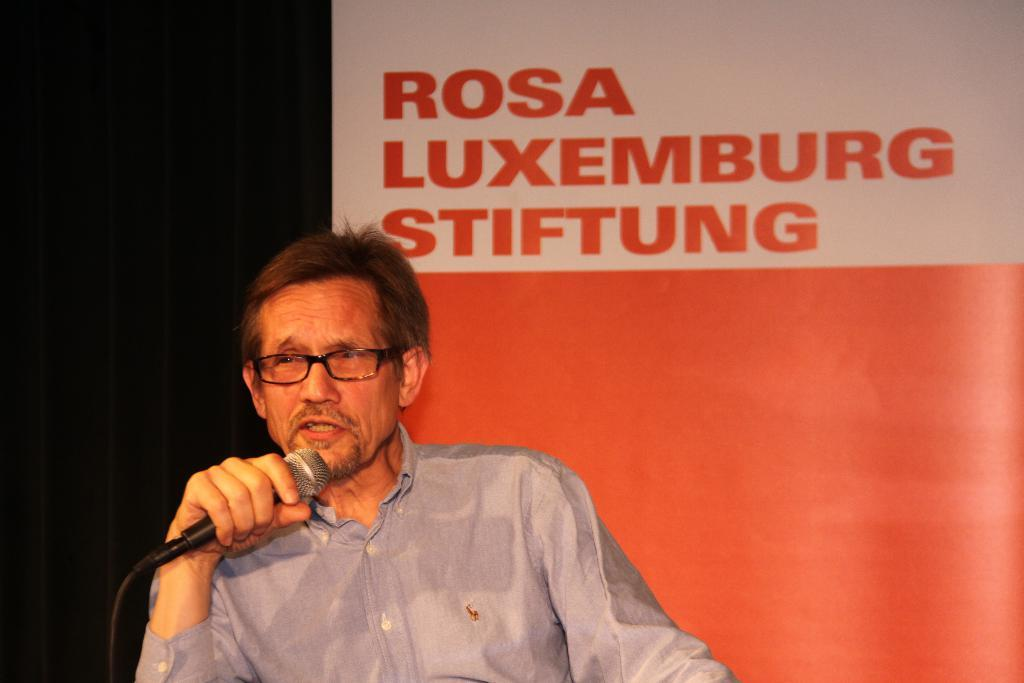What is the man in the image doing? The man is sitting in the image. What object is the man holding? The man is holding a microphone. Can you describe the man's appearance? The man is wearing glasses (specs). What can be seen in the background of the image? There is a poster in the background of the image. Are there any squirrels visible on the wall in the image? There are no squirrels or walls present in the image. 